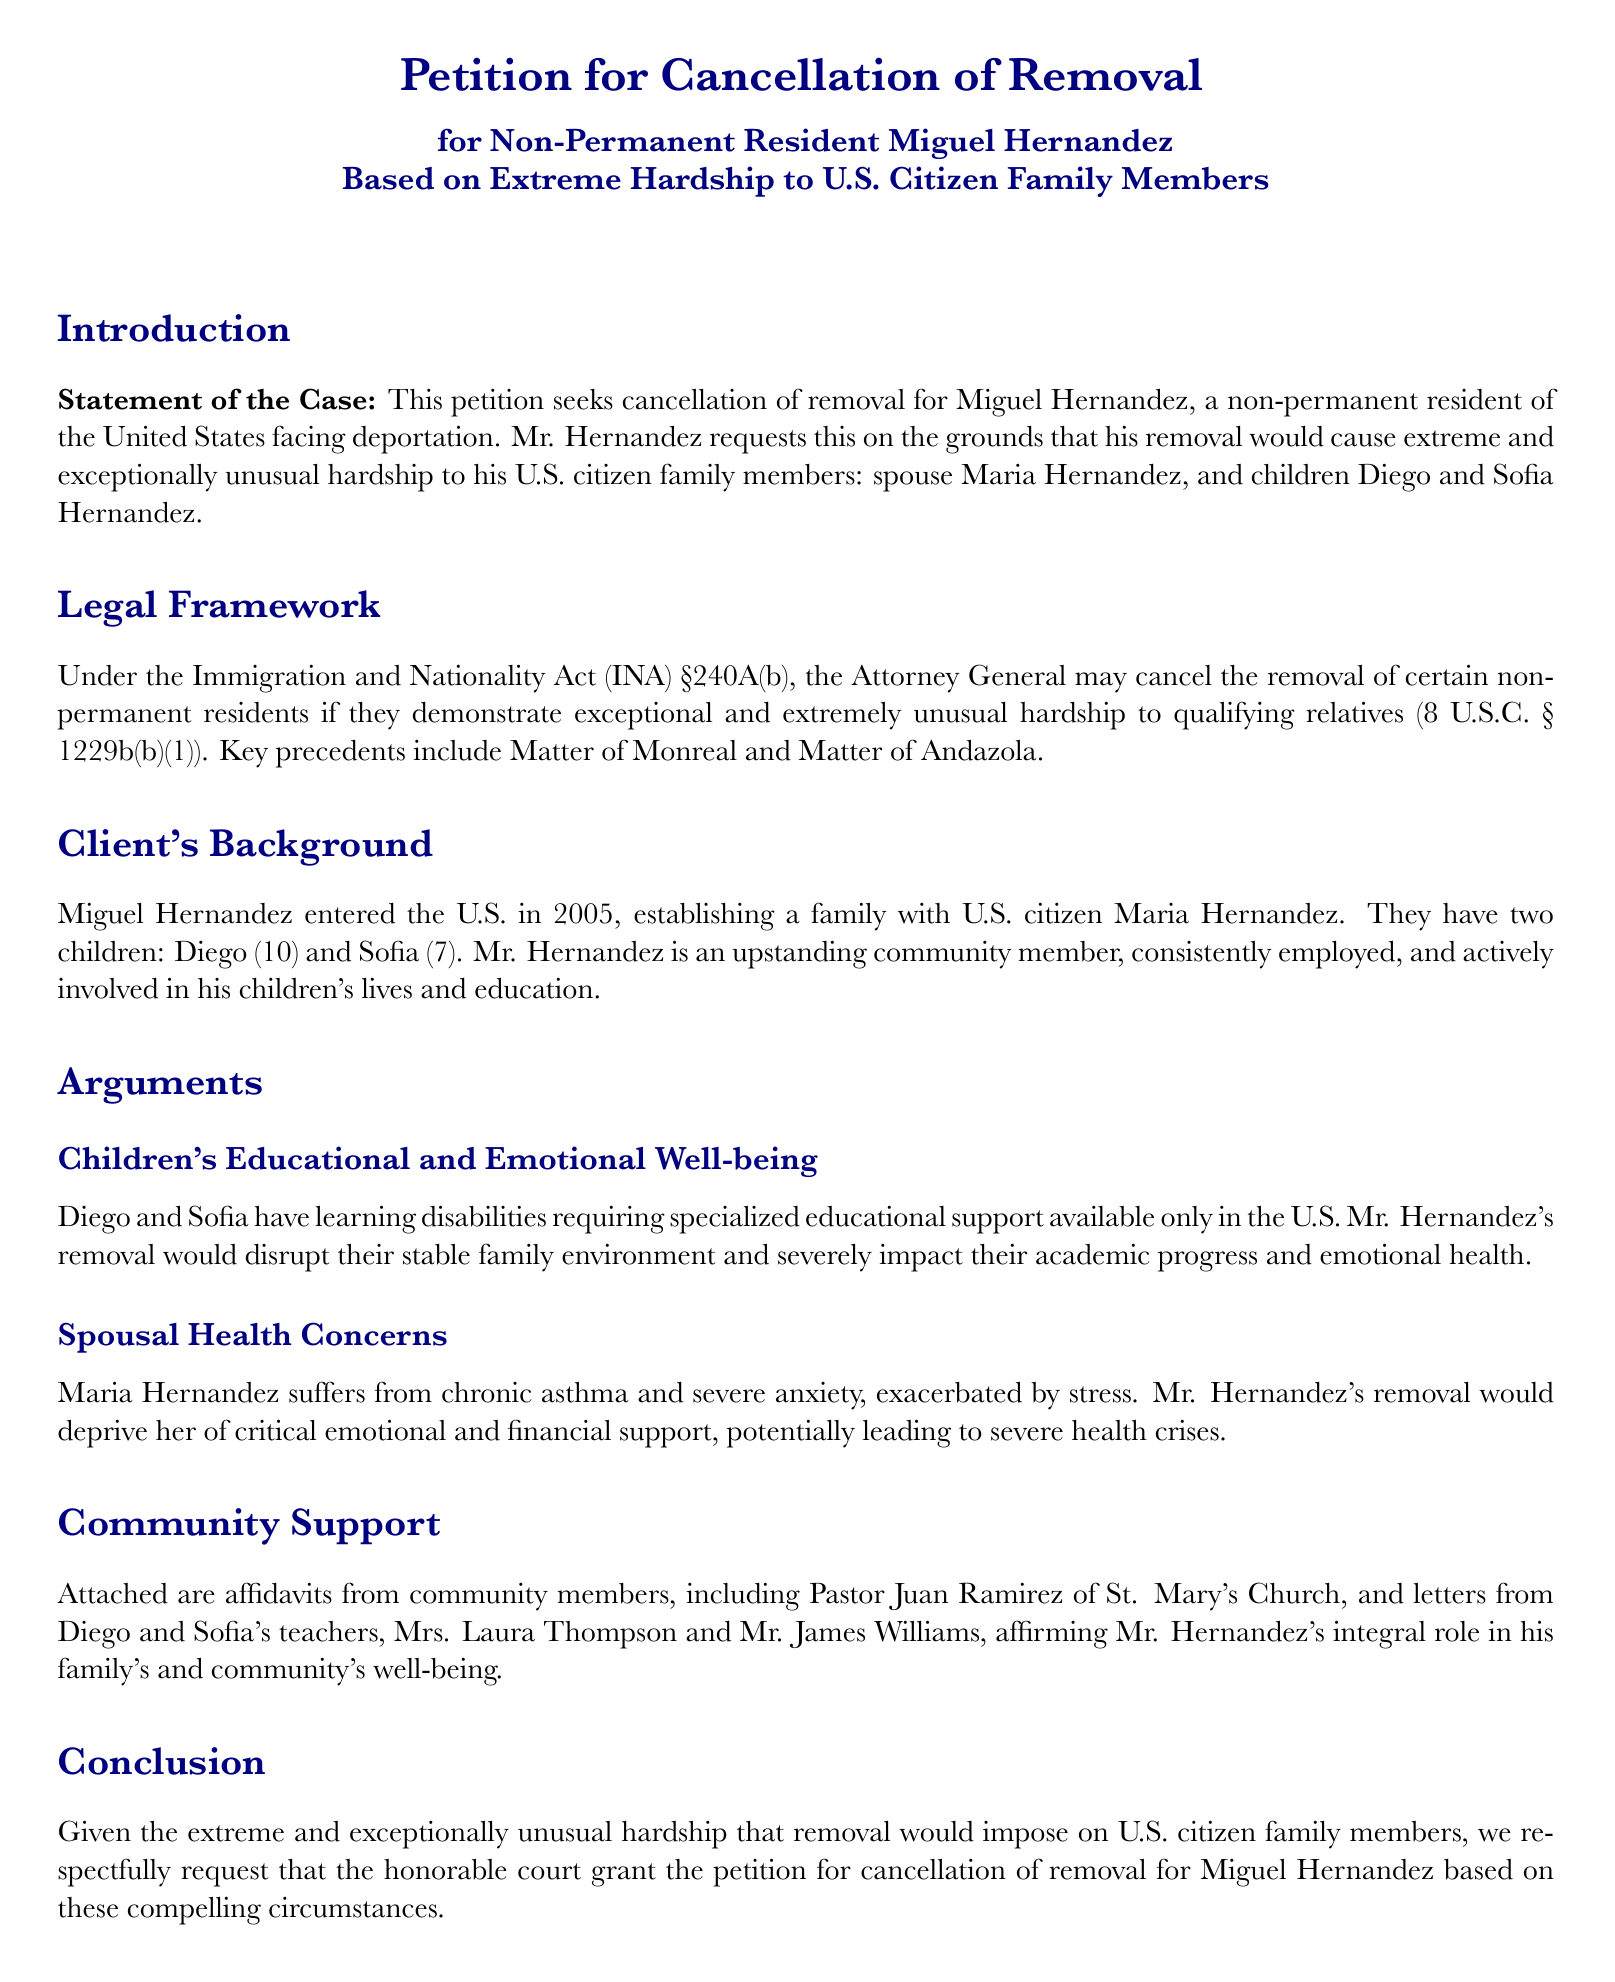What is the name of the petitioner? The petitioner is Miguel Hernandez, as stated in the title of the document.
Answer: Miguel Hernandez What year did Miguel Hernandez enter the U.S.? The document states that he entered in 2005.
Answer: 2005 Who is the spouse of Miguel Hernandez? The document specifies that his spouse is Maria Hernandez.
Answer: Maria Hernandez How many children does Miguel Hernandez have? The document indicates that he has two children.
Answer: Two What type of educational support do Diego and Sofia require? It is mentioned that they have learning disabilities requiring specialized educational support.
Answer: Specialized educational support What chronic condition does Maria Hernandez suffer from? The document notes that she suffers from chronic asthma.
Answer: Chronic asthma What role does Pastor Juan Ramirez have in this petition? He is mentioned as a community member providing an affidavit supporting Mr. Hernandez.
Answer: Affidavit provider What is the main legal basis for the petition? The legal framework references the Immigration and Nationality Act (INA) §240A(b).
Answer: INA §240A(b) Why is Miguel Hernandez's removal expected to affect his children's emotional health? The removal would disrupt their stable family environment.
Answer: Disrupt stable family environment What is the conclusion of the petition? The petition respectfully requests the honorable court to grant cancellation of removal for Miguel Hernandez based on extreme hardship.
Answer: Grant cancellation of removal 